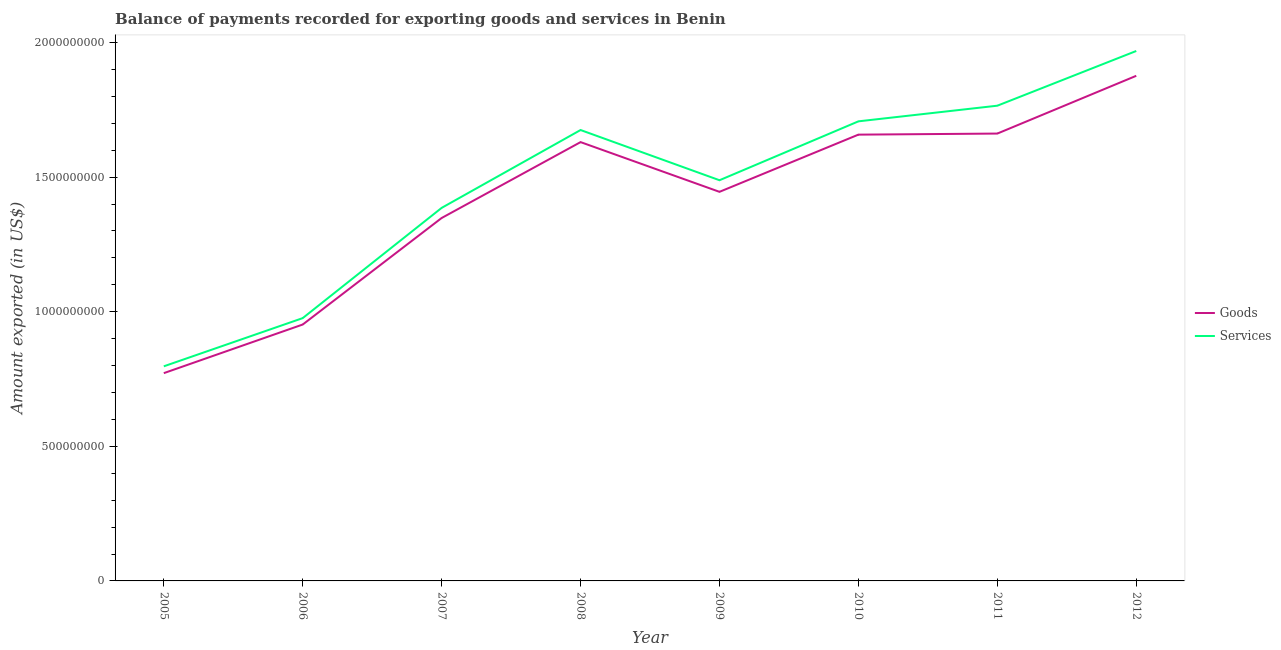Does the line corresponding to amount of services exported intersect with the line corresponding to amount of goods exported?
Offer a very short reply. No. What is the amount of goods exported in 2012?
Your answer should be very brief. 1.88e+09. Across all years, what is the maximum amount of services exported?
Provide a succinct answer. 1.97e+09. Across all years, what is the minimum amount of goods exported?
Give a very brief answer. 7.72e+08. In which year was the amount of goods exported minimum?
Offer a very short reply. 2005. What is the total amount of goods exported in the graph?
Keep it short and to the point. 1.13e+1. What is the difference between the amount of goods exported in 2011 and that in 2012?
Make the answer very short. -2.15e+08. What is the difference between the amount of goods exported in 2010 and the amount of services exported in 2008?
Offer a very short reply. -1.71e+07. What is the average amount of goods exported per year?
Keep it short and to the point. 1.42e+09. In the year 2006, what is the difference between the amount of services exported and amount of goods exported?
Provide a succinct answer. 2.38e+07. In how many years, is the amount of goods exported greater than 800000000 US$?
Ensure brevity in your answer.  7. What is the ratio of the amount of services exported in 2008 to that in 2010?
Make the answer very short. 0.98. Is the amount of services exported in 2008 less than that in 2012?
Keep it short and to the point. Yes. Is the difference between the amount of goods exported in 2008 and 2009 greater than the difference between the amount of services exported in 2008 and 2009?
Your answer should be compact. No. What is the difference between the highest and the second highest amount of services exported?
Your response must be concise. 2.03e+08. What is the difference between the highest and the lowest amount of services exported?
Provide a short and direct response. 1.17e+09. In how many years, is the amount of services exported greater than the average amount of services exported taken over all years?
Your answer should be very brief. 5. Is the sum of the amount of services exported in 2005 and 2009 greater than the maximum amount of goods exported across all years?
Your answer should be compact. Yes. Is the amount of goods exported strictly greater than the amount of services exported over the years?
Make the answer very short. No. How many years are there in the graph?
Your answer should be compact. 8. What is the difference between two consecutive major ticks on the Y-axis?
Your response must be concise. 5.00e+08. Are the values on the major ticks of Y-axis written in scientific E-notation?
Your answer should be very brief. No. Does the graph contain any zero values?
Offer a very short reply. No. How are the legend labels stacked?
Your answer should be very brief. Vertical. What is the title of the graph?
Offer a very short reply. Balance of payments recorded for exporting goods and services in Benin. Does "Crop" appear as one of the legend labels in the graph?
Make the answer very short. No. What is the label or title of the Y-axis?
Give a very brief answer. Amount exported (in US$). What is the Amount exported (in US$) in Goods in 2005?
Keep it short and to the point. 7.72e+08. What is the Amount exported (in US$) of Services in 2005?
Offer a terse response. 7.97e+08. What is the Amount exported (in US$) in Goods in 2006?
Give a very brief answer. 9.53e+08. What is the Amount exported (in US$) of Services in 2006?
Provide a succinct answer. 9.76e+08. What is the Amount exported (in US$) in Goods in 2007?
Make the answer very short. 1.35e+09. What is the Amount exported (in US$) in Services in 2007?
Your answer should be compact. 1.39e+09. What is the Amount exported (in US$) in Goods in 2008?
Give a very brief answer. 1.63e+09. What is the Amount exported (in US$) in Services in 2008?
Provide a succinct answer. 1.68e+09. What is the Amount exported (in US$) of Goods in 2009?
Offer a terse response. 1.45e+09. What is the Amount exported (in US$) in Services in 2009?
Offer a terse response. 1.49e+09. What is the Amount exported (in US$) of Goods in 2010?
Give a very brief answer. 1.66e+09. What is the Amount exported (in US$) of Services in 2010?
Offer a terse response. 1.71e+09. What is the Amount exported (in US$) of Goods in 2011?
Offer a very short reply. 1.66e+09. What is the Amount exported (in US$) in Services in 2011?
Provide a succinct answer. 1.77e+09. What is the Amount exported (in US$) of Goods in 2012?
Offer a terse response. 1.88e+09. What is the Amount exported (in US$) in Services in 2012?
Offer a very short reply. 1.97e+09. Across all years, what is the maximum Amount exported (in US$) in Goods?
Your answer should be very brief. 1.88e+09. Across all years, what is the maximum Amount exported (in US$) in Services?
Offer a very short reply. 1.97e+09. Across all years, what is the minimum Amount exported (in US$) of Goods?
Offer a terse response. 7.72e+08. Across all years, what is the minimum Amount exported (in US$) of Services?
Offer a very short reply. 7.97e+08. What is the total Amount exported (in US$) of Goods in the graph?
Offer a terse response. 1.13e+1. What is the total Amount exported (in US$) in Services in the graph?
Your answer should be compact. 1.18e+1. What is the difference between the Amount exported (in US$) in Goods in 2005 and that in 2006?
Offer a terse response. -1.81e+08. What is the difference between the Amount exported (in US$) of Services in 2005 and that in 2006?
Give a very brief answer. -1.79e+08. What is the difference between the Amount exported (in US$) of Goods in 2005 and that in 2007?
Your answer should be very brief. -5.76e+08. What is the difference between the Amount exported (in US$) of Services in 2005 and that in 2007?
Make the answer very short. -5.89e+08. What is the difference between the Amount exported (in US$) of Goods in 2005 and that in 2008?
Keep it short and to the point. -8.58e+08. What is the difference between the Amount exported (in US$) of Services in 2005 and that in 2008?
Your response must be concise. -8.78e+08. What is the difference between the Amount exported (in US$) in Goods in 2005 and that in 2009?
Your answer should be very brief. -6.74e+08. What is the difference between the Amount exported (in US$) in Services in 2005 and that in 2009?
Your answer should be compact. -6.91e+08. What is the difference between the Amount exported (in US$) of Goods in 2005 and that in 2010?
Give a very brief answer. -8.86e+08. What is the difference between the Amount exported (in US$) of Services in 2005 and that in 2010?
Provide a short and direct response. -9.10e+08. What is the difference between the Amount exported (in US$) of Goods in 2005 and that in 2011?
Keep it short and to the point. -8.90e+08. What is the difference between the Amount exported (in US$) of Services in 2005 and that in 2011?
Provide a succinct answer. -9.68e+08. What is the difference between the Amount exported (in US$) in Goods in 2005 and that in 2012?
Ensure brevity in your answer.  -1.10e+09. What is the difference between the Amount exported (in US$) in Services in 2005 and that in 2012?
Offer a terse response. -1.17e+09. What is the difference between the Amount exported (in US$) in Goods in 2006 and that in 2007?
Offer a very short reply. -3.96e+08. What is the difference between the Amount exported (in US$) in Services in 2006 and that in 2007?
Your answer should be very brief. -4.10e+08. What is the difference between the Amount exported (in US$) of Goods in 2006 and that in 2008?
Make the answer very short. -6.78e+08. What is the difference between the Amount exported (in US$) in Services in 2006 and that in 2008?
Your response must be concise. -6.99e+08. What is the difference between the Amount exported (in US$) in Goods in 2006 and that in 2009?
Ensure brevity in your answer.  -4.93e+08. What is the difference between the Amount exported (in US$) in Services in 2006 and that in 2009?
Your response must be concise. -5.12e+08. What is the difference between the Amount exported (in US$) of Goods in 2006 and that in 2010?
Your response must be concise. -7.05e+08. What is the difference between the Amount exported (in US$) in Services in 2006 and that in 2010?
Keep it short and to the point. -7.31e+08. What is the difference between the Amount exported (in US$) in Goods in 2006 and that in 2011?
Make the answer very short. -7.09e+08. What is the difference between the Amount exported (in US$) of Services in 2006 and that in 2011?
Offer a very short reply. -7.89e+08. What is the difference between the Amount exported (in US$) in Goods in 2006 and that in 2012?
Make the answer very short. -9.24e+08. What is the difference between the Amount exported (in US$) of Services in 2006 and that in 2012?
Ensure brevity in your answer.  -9.92e+08. What is the difference between the Amount exported (in US$) in Goods in 2007 and that in 2008?
Offer a very short reply. -2.82e+08. What is the difference between the Amount exported (in US$) of Services in 2007 and that in 2008?
Offer a very short reply. -2.89e+08. What is the difference between the Amount exported (in US$) in Goods in 2007 and that in 2009?
Keep it short and to the point. -9.72e+07. What is the difference between the Amount exported (in US$) in Services in 2007 and that in 2009?
Your answer should be very brief. -1.03e+08. What is the difference between the Amount exported (in US$) in Goods in 2007 and that in 2010?
Offer a terse response. -3.10e+08. What is the difference between the Amount exported (in US$) of Services in 2007 and that in 2010?
Keep it short and to the point. -3.21e+08. What is the difference between the Amount exported (in US$) in Goods in 2007 and that in 2011?
Your answer should be compact. -3.14e+08. What is the difference between the Amount exported (in US$) of Services in 2007 and that in 2011?
Your response must be concise. -3.80e+08. What is the difference between the Amount exported (in US$) in Goods in 2007 and that in 2012?
Your response must be concise. -5.28e+08. What is the difference between the Amount exported (in US$) of Services in 2007 and that in 2012?
Give a very brief answer. -5.83e+08. What is the difference between the Amount exported (in US$) in Goods in 2008 and that in 2009?
Your answer should be compact. 1.85e+08. What is the difference between the Amount exported (in US$) of Services in 2008 and that in 2009?
Make the answer very short. 1.87e+08. What is the difference between the Amount exported (in US$) of Goods in 2008 and that in 2010?
Your answer should be very brief. -2.78e+07. What is the difference between the Amount exported (in US$) in Services in 2008 and that in 2010?
Make the answer very short. -3.23e+07. What is the difference between the Amount exported (in US$) in Goods in 2008 and that in 2011?
Make the answer very short. -3.17e+07. What is the difference between the Amount exported (in US$) of Services in 2008 and that in 2011?
Your answer should be compact. -9.04e+07. What is the difference between the Amount exported (in US$) in Goods in 2008 and that in 2012?
Your answer should be very brief. -2.46e+08. What is the difference between the Amount exported (in US$) in Services in 2008 and that in 2012?
Provide a succinct answer. -2.94e+08. What is the difference between the Amount exported (in US$) in Goods in 2009 and that in 2010?
Give a very brief answer. -2.12e+08. What is the difference between the Amount exported (in US$) in Services in 2009 and that in 2010?
Your answer should be very brief. -2.19e+08. What is the difference between the Amount exported (in US$) in Goods in 2009 and that in 2011?
Offer a terse response. -2.16e+08. What is the difference between the Amount exported (in US$) of Services in 2009 and that in 2011?
Your response must be concise. -2.77e+08. What is the difference between the Amount exported (in US$) in Goods in 2009 and that in 2012?
Provide a short and direct response. -4.31e+08. What is the difference between the Amount exported (in US$) of Services in 2009 and that in 2012?
Your answer should be compact. -4.80e+08. What is the difference between the Amount exported (in US$) in Goods in 2010 and that in 2011?
Your answer should be compact. -3.97e+06. What is the difference between the Amount exported (in US$) of Services in 2010 and that in 2011?
Ensure brevity in your answer.  -5.81e+07. What is the difference between the Amount exported (in US$) of Goods in 2010 and that in 2012?
Provide a succinct answer. -2.19e+08. What is the difference between the Amount exported (in US$) in Services in 2010 and that in 2012?
Ensure brevity in your answer.  -2.61e+08. What is the difference between the Amount exported (in US$) of Goods in 2011 and that in 2012?
Make the answer very short. -2.15e+08. What is the difference between the Amount exported (in US$) of Services in 2011 and that in 2012?
Ensure brevity in your answer.  -2.03e+08. What is the difference between the Amount exported (in US$) in Goods in 2005 and the Amount exported (in US$) in Services in 2006?
Keep it short and to the point. -2.04e+08. What is the difference between the Amount exported (in US$) in Goods in 2005 and the Amount exported (in US$) in Services in 2007?
Provide a succinct answer. -6.14e+08. What is the difference between the Amount exported (in US$) of Goods in 2005 and the Amount exported (in US$) of Services in 2008?
Ensure brevity in your answer.  -9.03e+08. What is the difference between the Amount exported (in US$) of Goods in 2005 and the Amount exported (in US$) of Services in 2009?
Provide a short and direct response. -7.17e+08. What is the difference between the Amount exported (in US$) of Goods in 2005 and the Amount exported (in US$) of Services in 2010?
Your answer should be very brief. -9.36e+08. What is the difference between the Amount exported (in US$) in Goods in 2005 and the Amount exported (in US$) in Services in 2011?
Provide a short and direct response. -9.94e+08. What is the difference between the Amount exported (in US$) in Goods in 2005 and the Amount exported (in US$) in Services in 2012?
Keep it short and to the point. -1.20e+09. What is the difference between the Amount exported (in US$) in Goods in 2006 and the Amount exported (in US$) in Services in 2007?
Make the answer very short. -4.33e+08. What is the difference between the Amount exported (in US$) of Goods in 2006 and the Amount exported (in US$) of Services in 2008?
Keep it short and to the point. -7.23e+08. What is the difference between the Amount exported (in US$) in Goods in 2006 and the Amount exported (in US$) in Services in 2009?
Provide a short and direct response. -5.36e+08. What is the difference between the Amount exported (in US$) of Goods in 2006 and the Amount exported (in US$) of Services in 2010?
Keep it short and to the point. -7.55e+08. What is the difference between the Amount exported (in US$) of Goods in 2006 and the Amount exported (in US$) of Services in 2011?
Your answer should be very brief. -8.13e+08. What is the difference between the Amount exported (in US$) in Goods in 2006 and the Amount exported (in US$) in Services in 2012?
Your answer should be compact. -1.02e+09. What is the difference between the Amount exported (in US$) of Goods in 2007 and the Amount exported (in US$) of Services in 2008?
Ensure brevity in your answer.  -3.27e+08. What is the difference between the Amount exported (in US$) in Goods in 2007 and the Amount exported (in US$) in Services in 2009?
Provide a succinct answer. -1.40e+08. What is the difference between the Amount exported (in US$) of Goods in 2007 and the Amount exported (in US$) of Services in 2010?
Provide a succinct answer. -3.59e+08. What is the difference between the Amount exported (in US$) of Goods in 2007 and the Amount exported (in US$) of Services in 2011?
Your answer should be very brief. -4.17e+08. What is the difference between the Amount exported (in US$) in Goods in 2007 and the Amount exported (in US$) in Services in 2012?
Your answer should be very brief. -6.20e+08. What is the difference between the Amount exported (in US$) of Goods in 2008 and the Amount exported (in US$) of Services in 2009?
Make the answer very short. 1.42e+08. What is the difference between the Amount exported (in US$) in Goods in 2008 and the Amount exported (in US$) in Services in 2010?
Offer a terse response. -7.72e+07. What is the difference between the Amount exported (in US$) of Goods in 2008 and the Amount exported (in US$) of Services in 2011?
Offer a terse response. -1.35e+08. What is the difference between the Amount exported (in US$) in Goods in 2008 and the Amount exported (in US$) in Services in 2012?
Offer a terse response. -3.39e+08. What is the difference between the Amount exported (in US$) of Goods in 2009 and the Amount exported (in US$) of Services in 2010?
Keep it short and to the point. -2.62e+08. What is the difference between the Amount exported (in US$) in Goods in 2009 and the Amount exported (in US$) in Services in 2011?
Provide a short and direct response. -3.20e+08. What is the difference between the Amount exported (in US$) in Goods in 2009 and the Amount exported (in US$) in Services in 2012?
Your answer should be very brief. -5.23e+08. What is the difference between the Amount exported (in US$) in Goods in 2010 and the Amount exported (in US$) in Services in 2011?
Make the answer very short. -1.08e+08. What is the difference between the Amount exported (in US$) in Goods in 2010 and the Amount exported (in US$) in Services in 2012?
Make the answer very short. -3.11e+08. What is the difference between the Amount exported (in US$) of Goods in 2011 and the Amount exported (in US$) of Services in 2012?
Your answer should be compact. -3.07e+08. What is the average Amount exported (in US$) in Goods per year?
Your answer should be very brief. 1.42e+09. What is the average Amount exported (in US$) in Services per year?
Provide a short and direct response. 1.47e+09. In the year 2005, what is the difference between the Amount exported (in US$) of Goods and Amount exported (in US$) of Services?
Keep it short and to the point. -2.54e+07. In the year 2006, what is the difference between the Amount exported (in US$) of Goods and Amount exported (in US$) of Services?
Offer a terse response. -2.38e+07. In the year 2007, what is the difference between the Amount exported (in US$) in Goods and Amount exported (in US$) in Services?
Provide a succinct answer. -3.76e+07. In the year 2008, what is the difference between the Amount exported (in US$) in Goods and Amount exported (in US$) in Services?
Provide a short and direct response. -4.49e+07. In the year 2009, what is the difference between the Amount exported (in US$) in Goods and Amount exported (in US$) in Services?
Make the answer very short. -4.31e+07. In the year 2010, what is the difference between the Amount exported (in US$) in Goods and Amount exported (in US$) in Services?
Your response must be concise. -4.94e+07. In the year 2011, what is the difference between the Amount exported (in US$) of Goods and Amount exported (in US$) of Services?
Make the answer very short. -1.04e+08. In the year 2012, what is the difference between the Amount exported (in US$) in Goods and Amount exported (in US$) in Services?
Offer a very short reply. -9.22e+07. What is the ratio of the Amount exported (in US$) in Goods in 2005 to that in 2006?
Offer a very short reply. 0.81. What is the ratio of the Amount exported (in US$) in Services in 2005 to that in 2006?
Ensure brevity in your answer.  0.82. What is the ratio of the Amount exported (in US$) in Goods in 2005 to that in 2007?
Ensure brevity in your answer.  0.57. What is the ratio of the Amount exported (in US$) of Services in 2005 to that in 2007?
Provide a succinct answer. 0.58. What is the ratio of the Amount exported (in US$) of Goods in 2005 to that in 2008?
Provide a succinct answer. 0.47. What is the ratio of the Amount exported (in US$) of Services in 2005 to that in 2008?
Ensure brevity in your answer.  0.48. What is the ratio of the Amount exported (in US$) in Goods in 2005 to that in 2009?
Provide a short and direct response. 0.53. What is the ratio of the Amount exported (in US$) in Services in 2005 to that in 2009?
Your answer should be very brief. 0.54. What is the ratio of the Amount exported (in US$) of Goods in 2005 to that in 2010?
Offer a terse response. 0.47. What is the ratio of the Amount exported (in US$) of Services in 2005 to that in 2010?
Offer a very short reply. 0.47. What is the ratio of the Amount exported (in US$) in Goods in 2005 to that in 2011?
Your response must be concise. 0.46. What is the ratio of the Amount exported (in US$) of Services in 2005 to that in 2011?
Your response must be concise. 0.45. What is the ratio of the Amount exported (in US$) in Goods in 2005 to that in 2012?
Provide a short and direct response. 0.41. What is the ratio of the Amount exported (in US$) of Services in 2005 to that in 2012?
Ensure brevity in your answer.  0.41. What is the ratio of the Amount exported (in US$) in Goods in 2006 to that in 2007?
Your answer should be very brief. 0.71. What is the ratio of the Amount exported (in US$) of Services in 2006 to that in 2007?
Offer a terse response. 0.7. What is the ratio of the Amount exported (in US$) of Goods in 2006 to that in 2008?
Make the answer very short. 0.58. What is the ratio of the Amount exported (in US$) of Services in 2006 to that in 2008?
Your response must be concise. 0.58. What is the ratio of the Amount exported (in US$) in Goods in 2006 to that in 2009?
Offer a terse response. 0.66. What is the ratio of the Amount exported (in US$) of Services in 2006 to that in 2009?
Offer a very short reply. 0.66. What is the ratio of the Amount exported (in US$) of Goods in 2006 to that in 2010?
Offer a very short reply. 0.57. What is the ratio of the Amount exported (in US$) in Services in 2006 to that in 2010?
Give a very brief answer. 0.57. What is the ratio of the Amount exported (in US$) of Goods in 2006 to that in 2011?
Your answer should be very brief. 0.57. What is the ratio of the Amount exported (in US$) of Services in 2006 to that in 2011?
Your response must be concise. 0.55. What is the ratio of the Amount exported (in US$) in Goods in 2006 to that in 2012?
Your answer should be very brief. 0.51. What is the ratio of the Amount exported (in US$) in Services in 2006 to that in 2012?
Provide a short and direct response. 0.5. What is the ratio of the Amount exported (in US$) in Goods in 2007 to that in 2008?
Ensure brevity in your answer.  0.83. What is the ratio of the Amount exported (in US$) in Services in 2007 to that in 2008?
Offer a terse response. 0.83. What is the ratio of the Amount exported (in US$) in Goods in 2007 to that in 2009?
Your response must be concise. 0.93. What is the ratio of the Amount exported (in US$) in Services in 2007 to that in 2009?
Your answer should be compact. 0.93. What is the ratio of the Amount exported (in US$) in Goods in 2007 to that in 2010?
Make the answer very short. 0.81. What is the ratio of the Amount exported (in US$) in Services in 2007 to that in 2010?
Your answer should be very brief. 0.81. What is the ratio of the Amount exported (in US$) in Goods in 2007 to that in 2011?
Ensure brevity in your answer.  0.81. What is the ratio of the Amount exported (in US$) in Services in 2007 to that in 2011?
Ensure brevity in your answer.  0.79. What is the ratio of the Amount exported (in US$) in Goods in 2007 to that in 2012?
Offer a very short reply. 0.72. What is the ratio of the Amount exported (in US$) of Services in 2007 to that in 2012?
Your response must be concise. 0.7. What is the ratio of the Amount exported (in US$) of Goods in 2008 to that in 2009?
Your answer should be very brief. 1.13. What is the ratio of the Amount exported (in US$) of Services in 2008 to that in 2009?
Your answer should be compact. 1.13. What is the ratio of the Amount exported (in US$) of Goods in 2008 to that in 2010?
Give a very brief answer. 0.98. What is the ratio of the Amount exported (in US$) of Services in 2008 to that in 2010?
Ensure brevity in your answer.  0.98. What is the ratio of the Amount exported (in US$) of Goods in 2008 to that in 2011?
Provide a succinct answer. 0.98. What is the ratio of the Amount exported (in US$) in Services in 2008 to that in 2011?
Offer a terse response. 0.95. What is the ratio of the Amount exported (in US$) in Goods in 2008 to that in 2012?
Provide a succinct answer. 0.87. What is the ratio of the Amount exported (in US$) of Services in 2008 to that in 2012?
Offer a terse response. 0.85. What is the ratio of the Amount exported (in US$) of Goods in 2009 to that in 2010?
Offer a very short reply. 0.87. What is the ratio of the Amount exported (in US$) of Services in 2009 to that in 2010?
Provide a succinct answer. 0.87. What is the ratio of the Amount exported (in US$) of Goods in 2009 to that in 2011?
Provide a short and direct response. 0.87. What is the ratio of the Amount exported (in US$) in Services in 2009 to that in 2011?
Make the answer very short. 0.84. What is the ratio of the Amount exported (in US$) of Goods in 2009 to that in 2012?
Your response must be concise. 0.77. What is the ratio of the Amount exported (in US$) of Services in 2009 to that in 2012?
Your answer should be compact. 0.76. What is the ratio of the Amount exported (in US$) in Goods in 2010 to that in 2011?
Offer a terse response. 1. What is the ratio of the Amount exported (in US$) of Services in 2010 to that in 2011?
Your response must be concise. 0.97. What is the ratio of the Amount exported (in US$) of Goods in 2010 to that in 2012?
Offer a terse response. 0.88. What is the ratio of the Amount exported (in US$) of Services in 2010 to that in 2012?
Your response must be concise. 0.87. What is the ratio of the Amount exported (in US$) in Goods in 2011 to that in 2012?
Ensure brevity in your answer.  0.89. What is the ratio of the Amount exported (in US$) in Services in 2011 to that in 2012?
Provide a succinct answer. 0.9. What is the difference between the highest and the second highest Amount exported (in US$) in Goods?
Ensure brevity in your answer.  2.15e+08. What is the difference between the highest and the second highest Amount exported (in US$) in Services?
Provide a succinct answer. 2.03e+08. What is the difference between the highest and the lowest Amount exported (in US$) of Goods?
Keep it short and to the point. 1.10e+09. What is the difference between the highest and the lowest Amount exported (in US$) in Services?
Provide a succinct answer. 1.17e+09. 